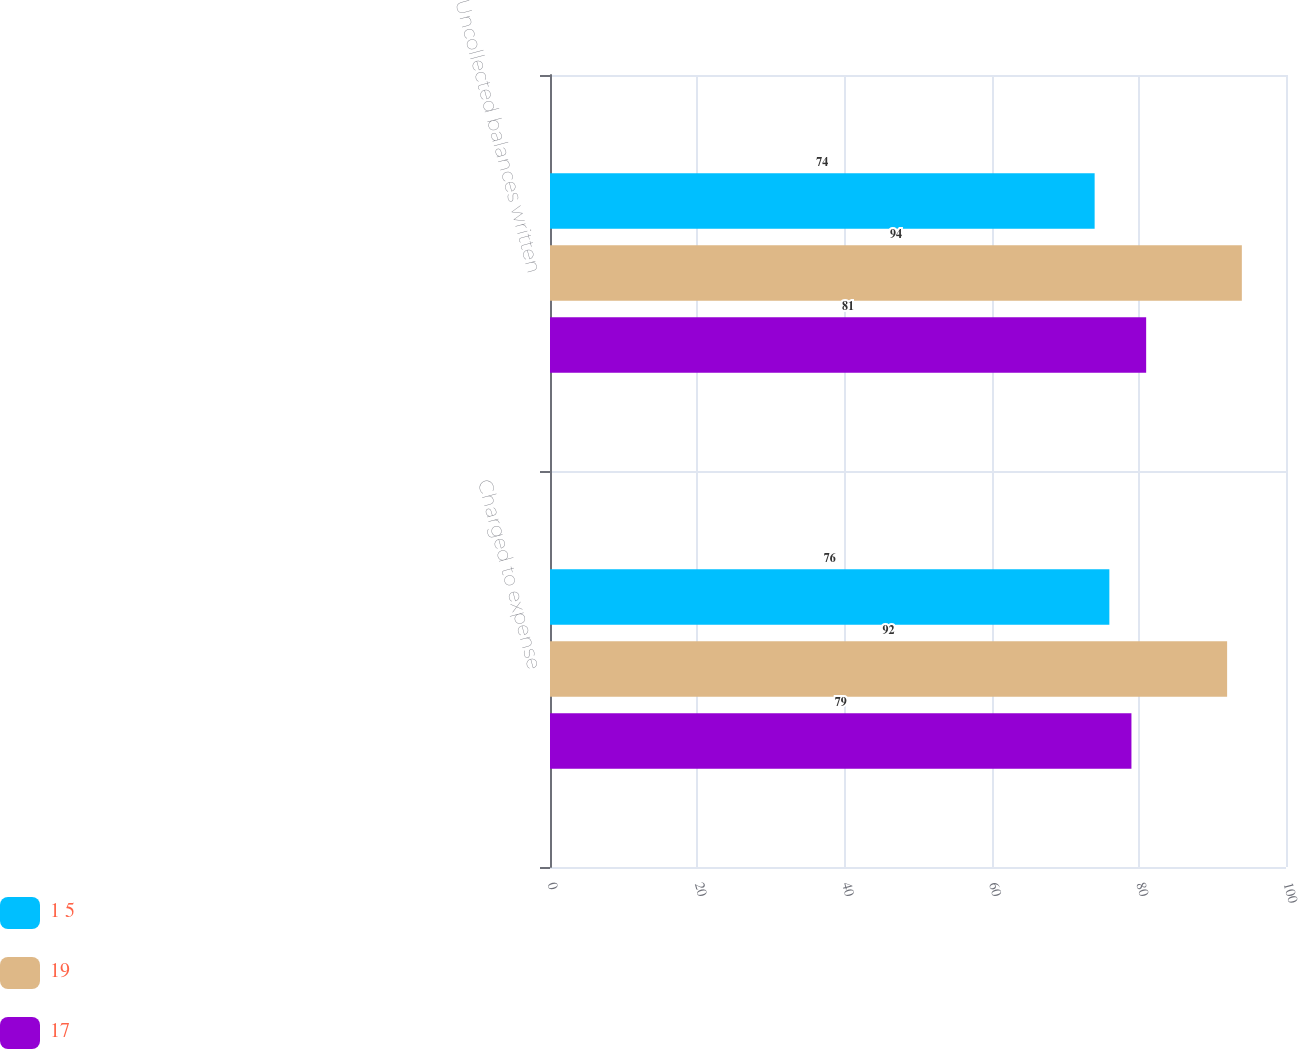Convert chart to OTSL. <chart><loc_0><loc_0><loc_500><loc_500><stacked_bar_chart><ecel><fcel>Charged to expense<fcel>Uncollected balances written<nl><fcel>1 5<fcel>76<fcel>74<nl><fcel>19<fcel>92<fcel>94<nl><fcel>17<fcel>79<fcel>81<nl></chart> 